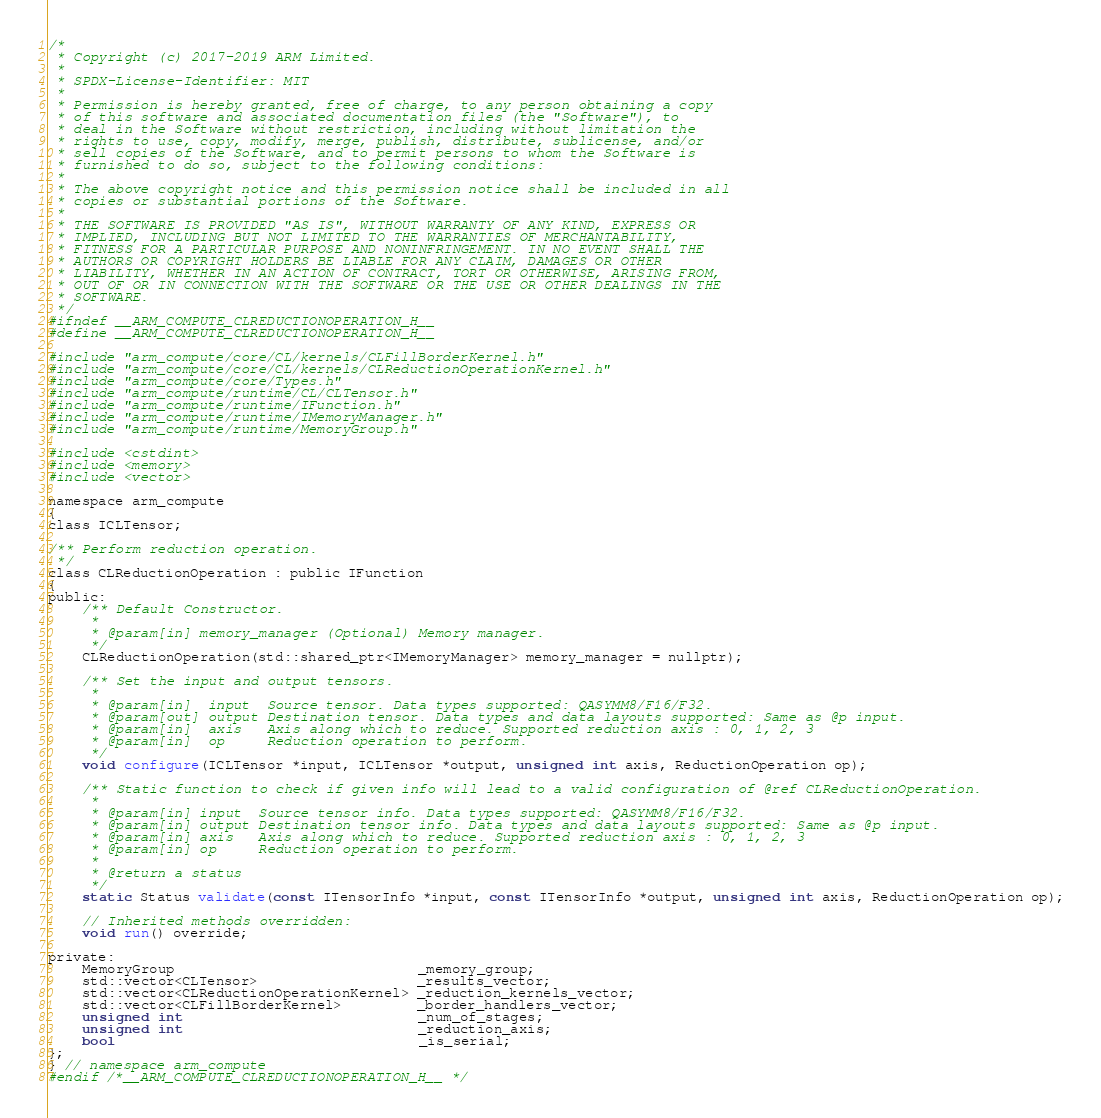Convert code to text. <code><loc_0><loc_0><loc_500><loc_500><_C_>/*
 * Copyright (c) 2017-2019 ARM Limited.
 *
 * SPDX-License-Identifier: MIT
 *
 * Permission is hereby granted, free of charge, to any person obtaining a copy
 * of this software and associated documentation files (the "Software"), to
 * deal in the Software without restriction, including without limitation the
 * rights to use, copy, modify, merge, publish, distribute, sublicense, and/or
 * sell copies of the Software, and to permit persons to whom the Software is
 * furnished to do so, subject to the following conditions:
 *
 * The above copyright notice and this permission notice shall be included in all
 * copies or substantial portions of the Software.
 *
 * THE SOFTWARE IS PROVIDED "AS IS", WITHOUT WARRANTY OF ANY KIND, EXPRESS OR
 * IMPLIED, INCLUDING BUT NOT LIMITED TO THE WARRANTIES OF MERCHANTABILITY,
 * FITNESS FOR A PARTICULAR PURPOSE AND NONINFRINGEMENT. IN NO EVENT SHALL THE
 * AUTHORS OR COPYRIGHT HOLDERS BE LIABLE FOR ANY CLAIM, DAMAGES OR OTHER
 * LIABILITY, WHETHER IN AN ACTION OF CONTRACT, TORT OR OTHERWISE, ARISING FROM,
 * OUT OF OR IN CONNECTION WITH THE SOFTWARE OR THE USE OR OTHER DEALINGS IN THE
 * SOFTWARE.
 */
#ifndef __ARM_COMPUTE_CLREDUCTIONOPERATION_H__
#define __ARM_COMPUTE_CLREDUCTIONOPERATION_H__

#include "arm_compute/core/CL/kernels/CLFillBorderKernel.h"
#include "arm_compute/core/CL/kernels/CLReductionOperationKernel.h"
#include "arm_compute/core/Types.h"
#include "arm_compute/runtime/CL/CLTensor.h"
#include "arm_compute/runtime/IFunction.h"
#include "arm_compute/runtime/IMemoryManager.h"
#include "arm_compute/runtime/MemoryGroup.h"

#include <cstdint>
#include <memory>
#include <vector>

namespace arm_compute
{
class ICLTensor;

/** Perform reduction operation.
 */
class CLReductionOperation : public IFunction
{
public:
    /** Default Constructor.
     *
     * @param[in] memory_manager (Optional) Memory manager.
     */
    CLReductionOperation(std::shared_ptr<IMemoryManager> memory_manager = nullptr);

    /** Set the input and output tensors.
     *
     * @param[in]  input  Source tensor. Data types supported: QASYMM8/F16/F32.
     * @param[out] output Destination tensor. Data types and data layouts supported: Same as @p input.
     * @param[in]  axis   Axis along which to reduce. Supported reduction axis : 0, 1, 2, 3
     * @param[in]  op     Reduction operation to perform.
     */
    void configure(ICLTensor *input, ICLTensor *output, unsigned int axis, ReductionOperation op);

    /** Static function to check if given info will lead to a valid configuration of @ref CLReductionOperation.
     *
     * @param[in] input  Source tensor info. Data types supported: QASYMM8/F16/F32.
     * @param[in] output Destination tensor info. Data types and data layouts supported: Same as @p input.
     * @param[in] axis   Axis along which to reduce. Supported reduction axis : 0, 1, 2, 3
     * @param[in] op     Reduction operation to perform.
     *
     * @return a status
     */
    static Status validate(const ITensorInfo *input, const ITensorInfo *output, unsigned int axis, ReductionOperation op);

    // Inherited methods overridden:
    void run() override;

private:
    MemoryGroup                             _memory_group;
    std::vector<CLTensor>                   _results_vector;
    std::vector<CLReductionOperationKernel> _reduction_kernels_vector;
    std::vector<CLFillBorderKernel>         _border_handlers_vector;
    unsigned int                            _num_of_stages;
    unsigned int                            _reduction_axis;
    bool                                    _is_serial;
};
} // namespace arm_compute
#endif /*__ARM_COMPUTE_CLREDUCTIONOPERATION_H__ */
</code> 